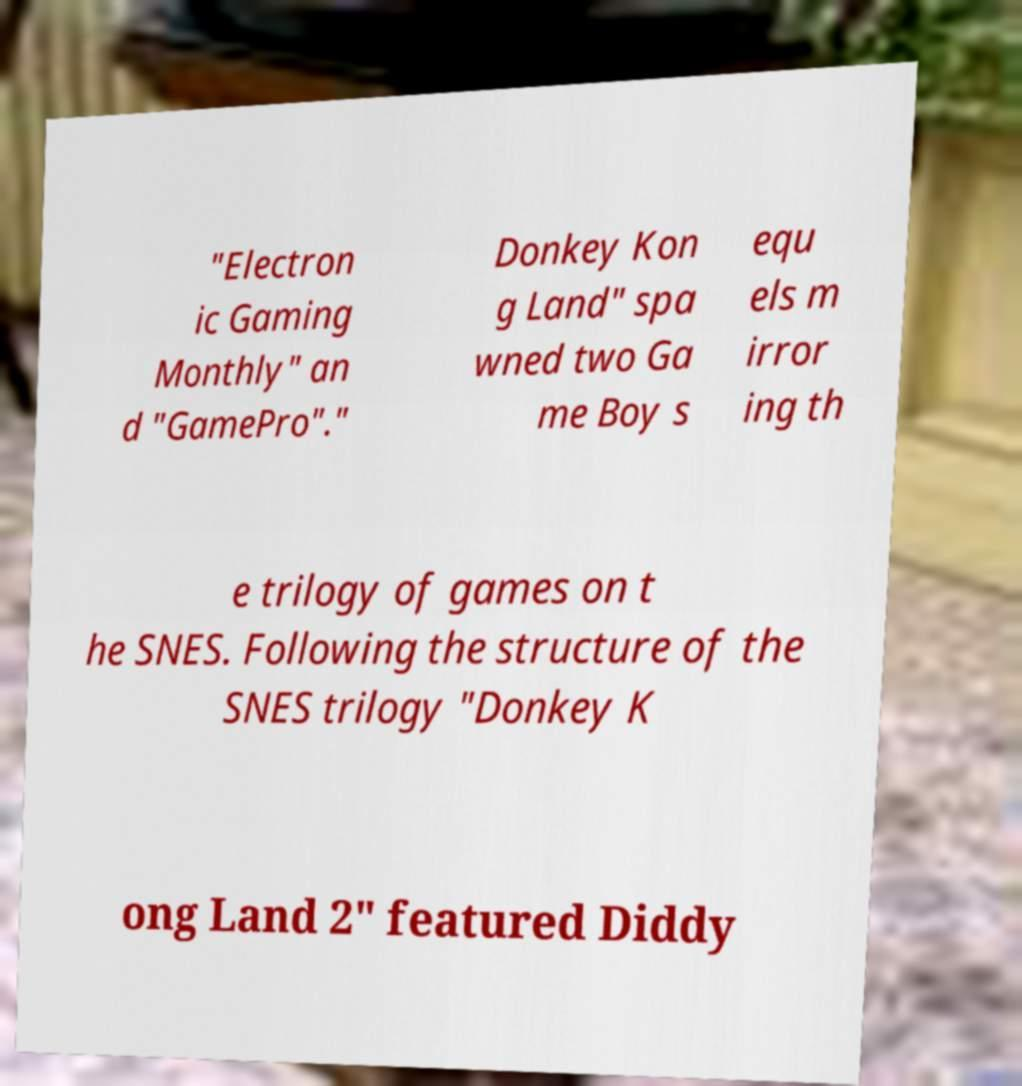Please identify and transcribe the text found in this image. "Electron ic Gaming Monthly" an d "GamePro"." Donkey Kon g Land" spa wned two Ga me Boy s equ els m irror ing th e trilogy of games on t he SNES. Following the structure of the SNES trilogy "Donkey K ong Land 2" featured Diddy 